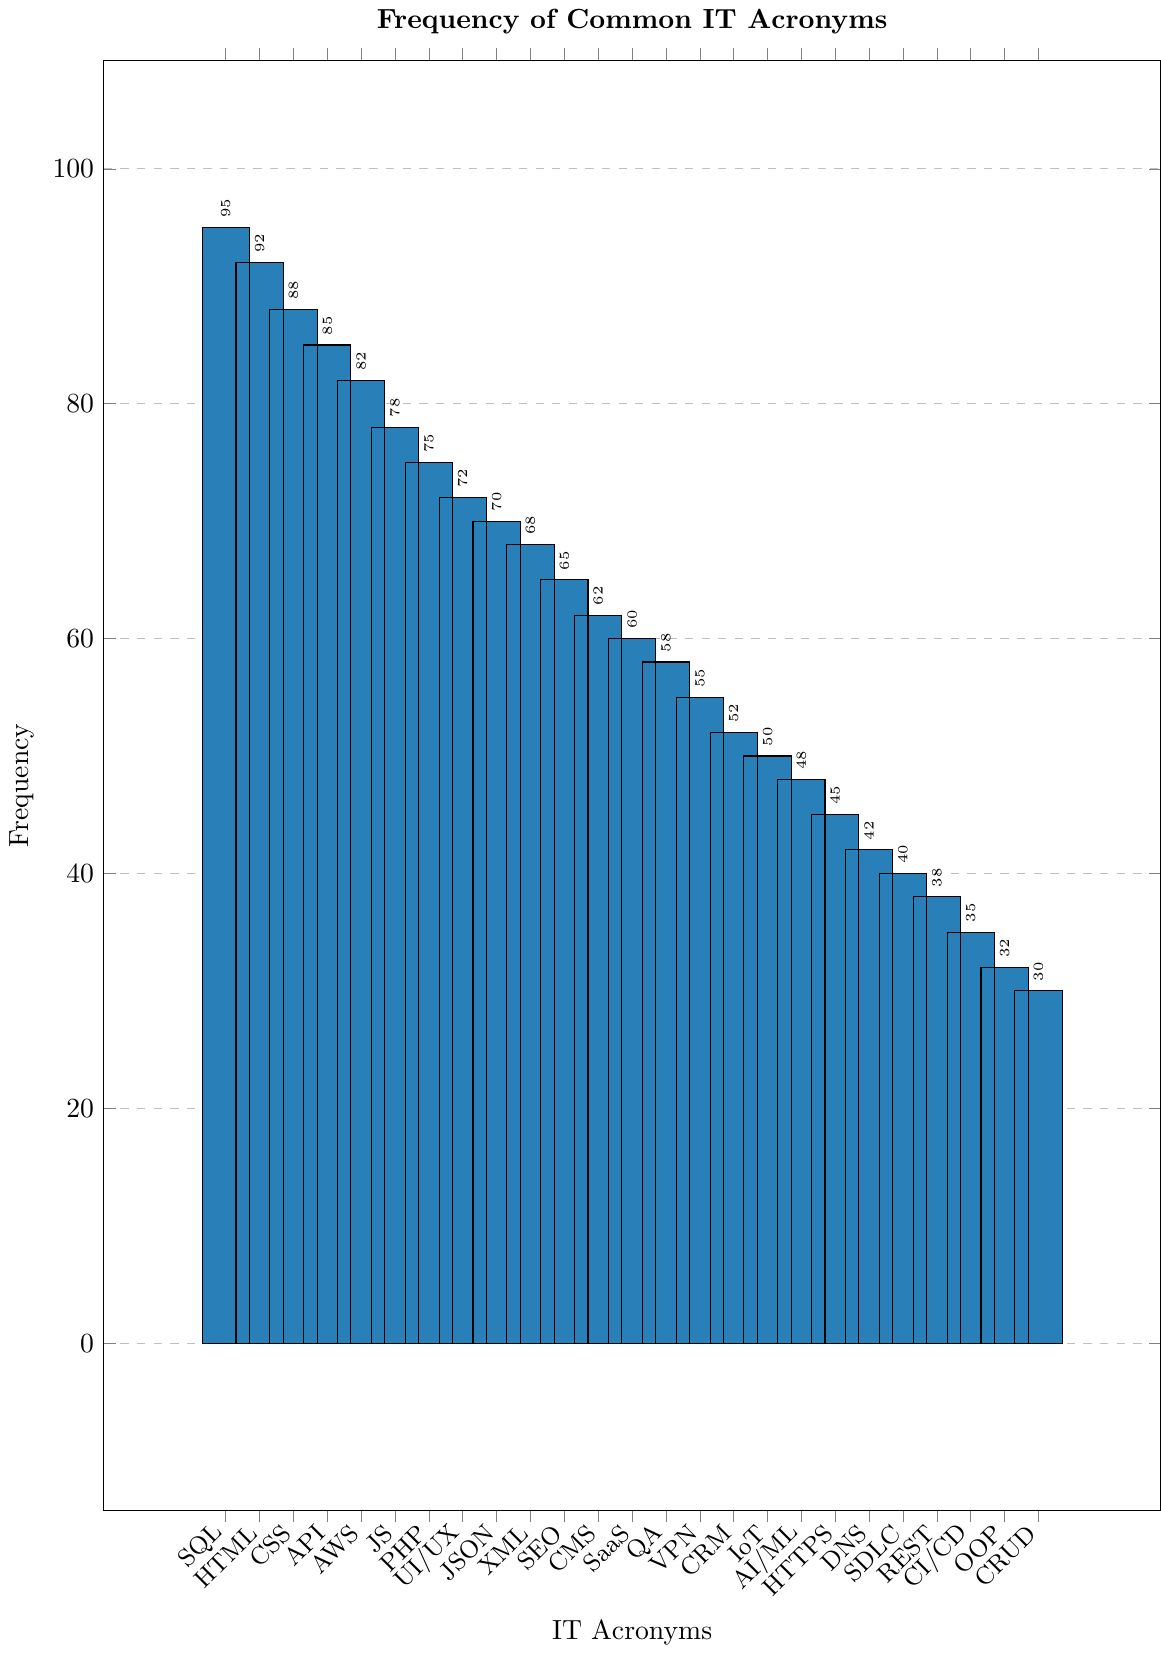Which acronym is the most frequent in the dataset? The top of the bar chart indicates the highest bar, which represents SQL with a frequency of 95.
Answer: SQL How much more frequent is 'SQL' compared to 'CMS'? The frequency of SQL is 95 while CMS is 62. Subtracting the two values gives 95 - 62 = 33.
Answer: 33 List all acronyms with a frequency above 80. By observing the bars that exceed the tick mark of 80 on the y-axis, the acronyms are SQL, HTML, CSS, API, and AWS.
Answer: SQL, HTML, CSS, API, AWS What is the average frequency of 'AWS', 'JS', and 'PHP'? Frequencies are AWS (82), JS (78), and PHP (75). Sum these values (82 + 78 + 75 = 235) and divide by 3 (235 / 3 ≈ 78.33).
Answer: 78.33 Are there more acronyms with a frequency above 70 or below 40? Count acronyms with frequencies above 70: 7 (SQL, HTML, CSS, API, AWS, JS, PHP) and those below 40: 8 (SDLC, REST, CI/CD, OOP, CRUD). Thus, there are more below 40.
Answer: Below 40 Which acronyms have exactly the same frequency? Check for bars of the same height: There are no pairs of acronyms with the exact same frequency.
Answer: None How many acronyms have a frequency between 50 and 70? Check the bars whose heights fall between the tick marks for 50 and 70: CRM (52), IoT (50), AI/ML (48), HTTPS (45), DNS (42) - 5 acronyms.
Answer: 5 Is 'UI/UX' more frequent than 'CMS'? Comparing the heights: UI/UX (72) is higher than CMS (62).
Answer: Yes Calculate the total frequency for 'API', 'UI/UX', and 'JSON'. Frequencies are API (85), UI/UX (72), JSON (70). Sum these (85 + 72 + 70 = 227).
Answer: 227 Which acronym has the lowest frequency? The smallest bar corresponds to CRUD with a frequency of 30.
Answer: CRUD 